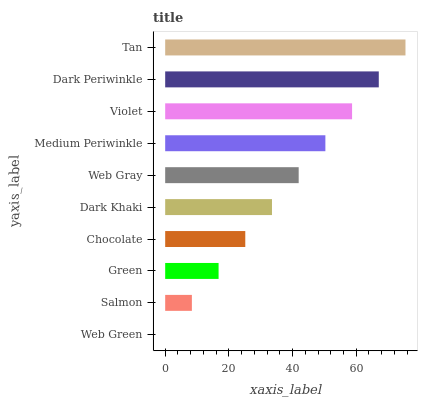Is Web Green the minimum?
Answer yes or no. Yes. Is Tan the maximum?
Answer yes or no. Yes. Is Salmon the minimum?
Answer yes or no. No. Is Salmon the maximum?
Answer yes or no. No. Is Salmon greater than Web Green?
Answer yes or no. Yes. Is Web Green less than Salmon?
Answer yes or no. Yes. Is Web Green greater than Salmon?
Answer yes or no. No. Is Salmon less than Web Green?
Answer yes or no. No. Is Web Gray the high median?
Answer yes or no. Yes. Is Dark Khaki the low median?
Answer yes or no. Yes. Is Salmon the high median?
Answer yes or no. No. Is Green the low median?
Answer yes or no. No. 